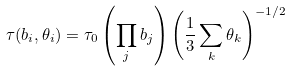Convert formula to latex. <formula><loc_0><loc_0><loc_500><loc_500>\tau ( b _ { i } , \theta _ { i } ) = \tau _ { 0 } \left ( \prod _ { j } b _ { j } \right ) \left ( \frac { 1 } { 3 } \sum _ { k } \theta _ { k } \right ) ^ { - 1 / 2 }</formula> 